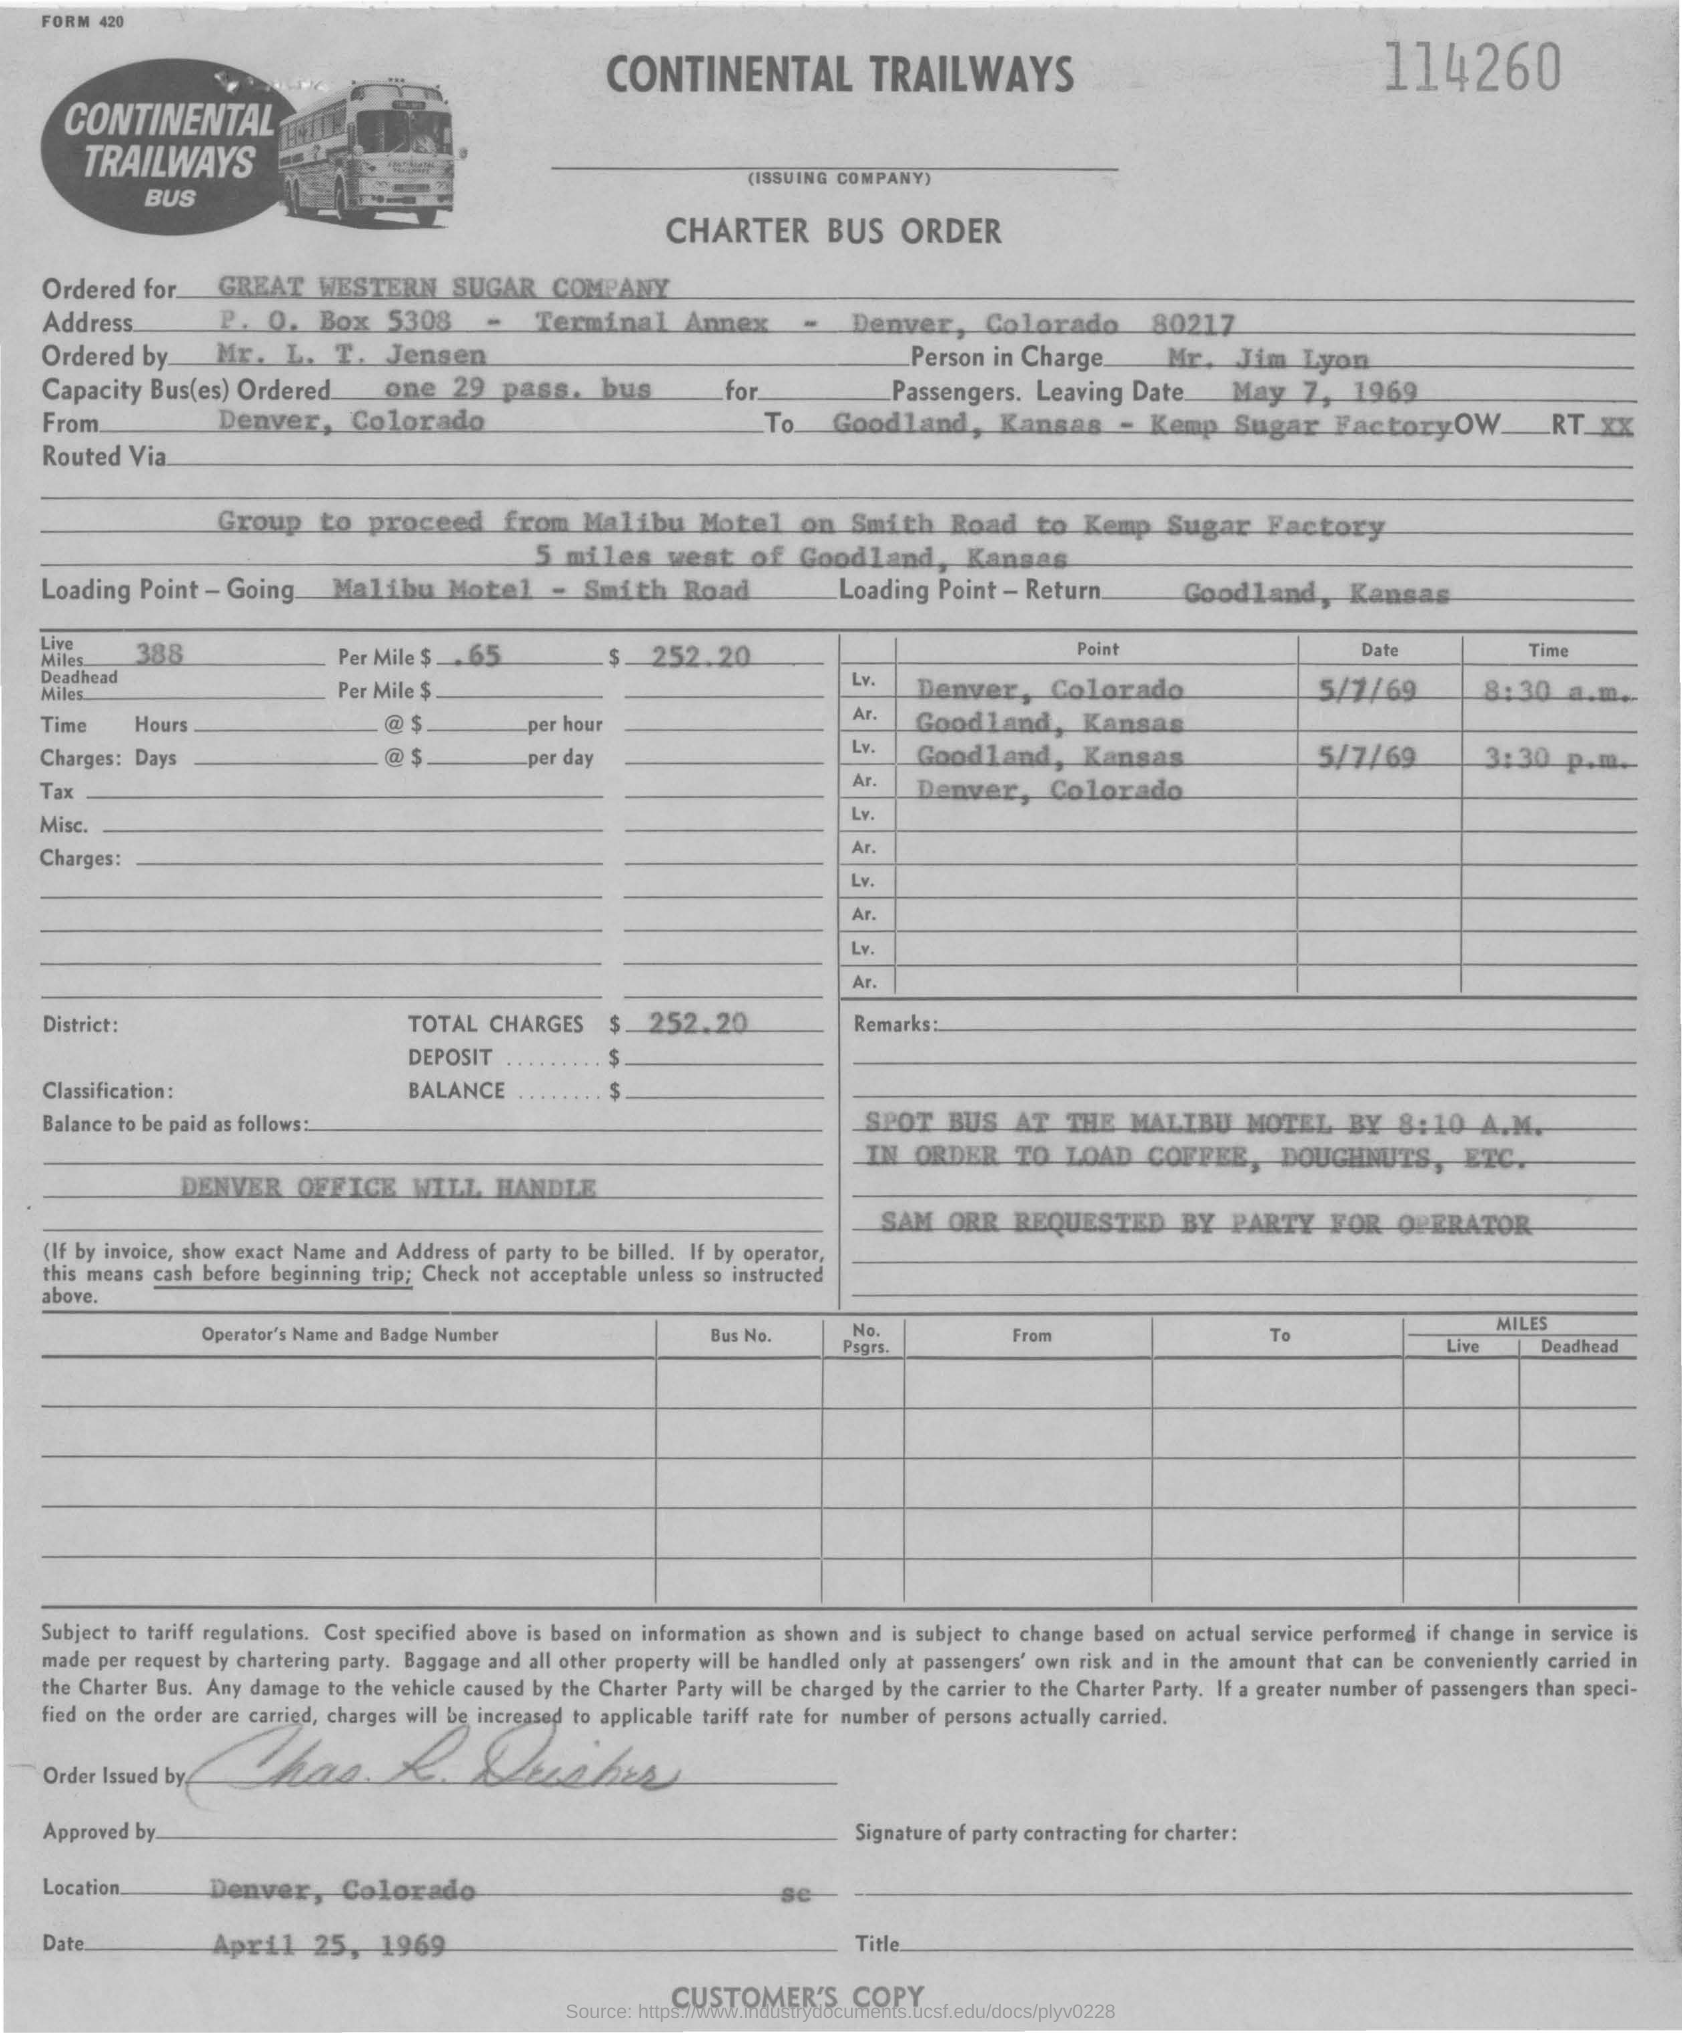Who ordered the bus ?
Keep it short and to the point. MR.  L. T.  JENSEN. What is "capacity bus(es) ordered" ?
Offer a very short reply. One 29 pass. bus. Who is the person in charge ?
Offer a terse response. Mr. jim lyon. From where the bus has started ?
Your answer should be compact. DENVER, COLORADO. What is the  destination of the  bus ?
Your answer should be compact. GOODLAND, KANSAS- KEMP SUGAR FACTORY. What is the charge of the bus per one mile in $ ?
Provide a succinct answer. $ .65. What are the total charges for the bus ?
Offer a very short reply. $252.20. What is the loading point while going ?
Your answer should be compact. MALIBU MOTEL- SMITH ROAD. What is the loading point in return ?
Keep it short and to the point. Goodland ,kansas. 